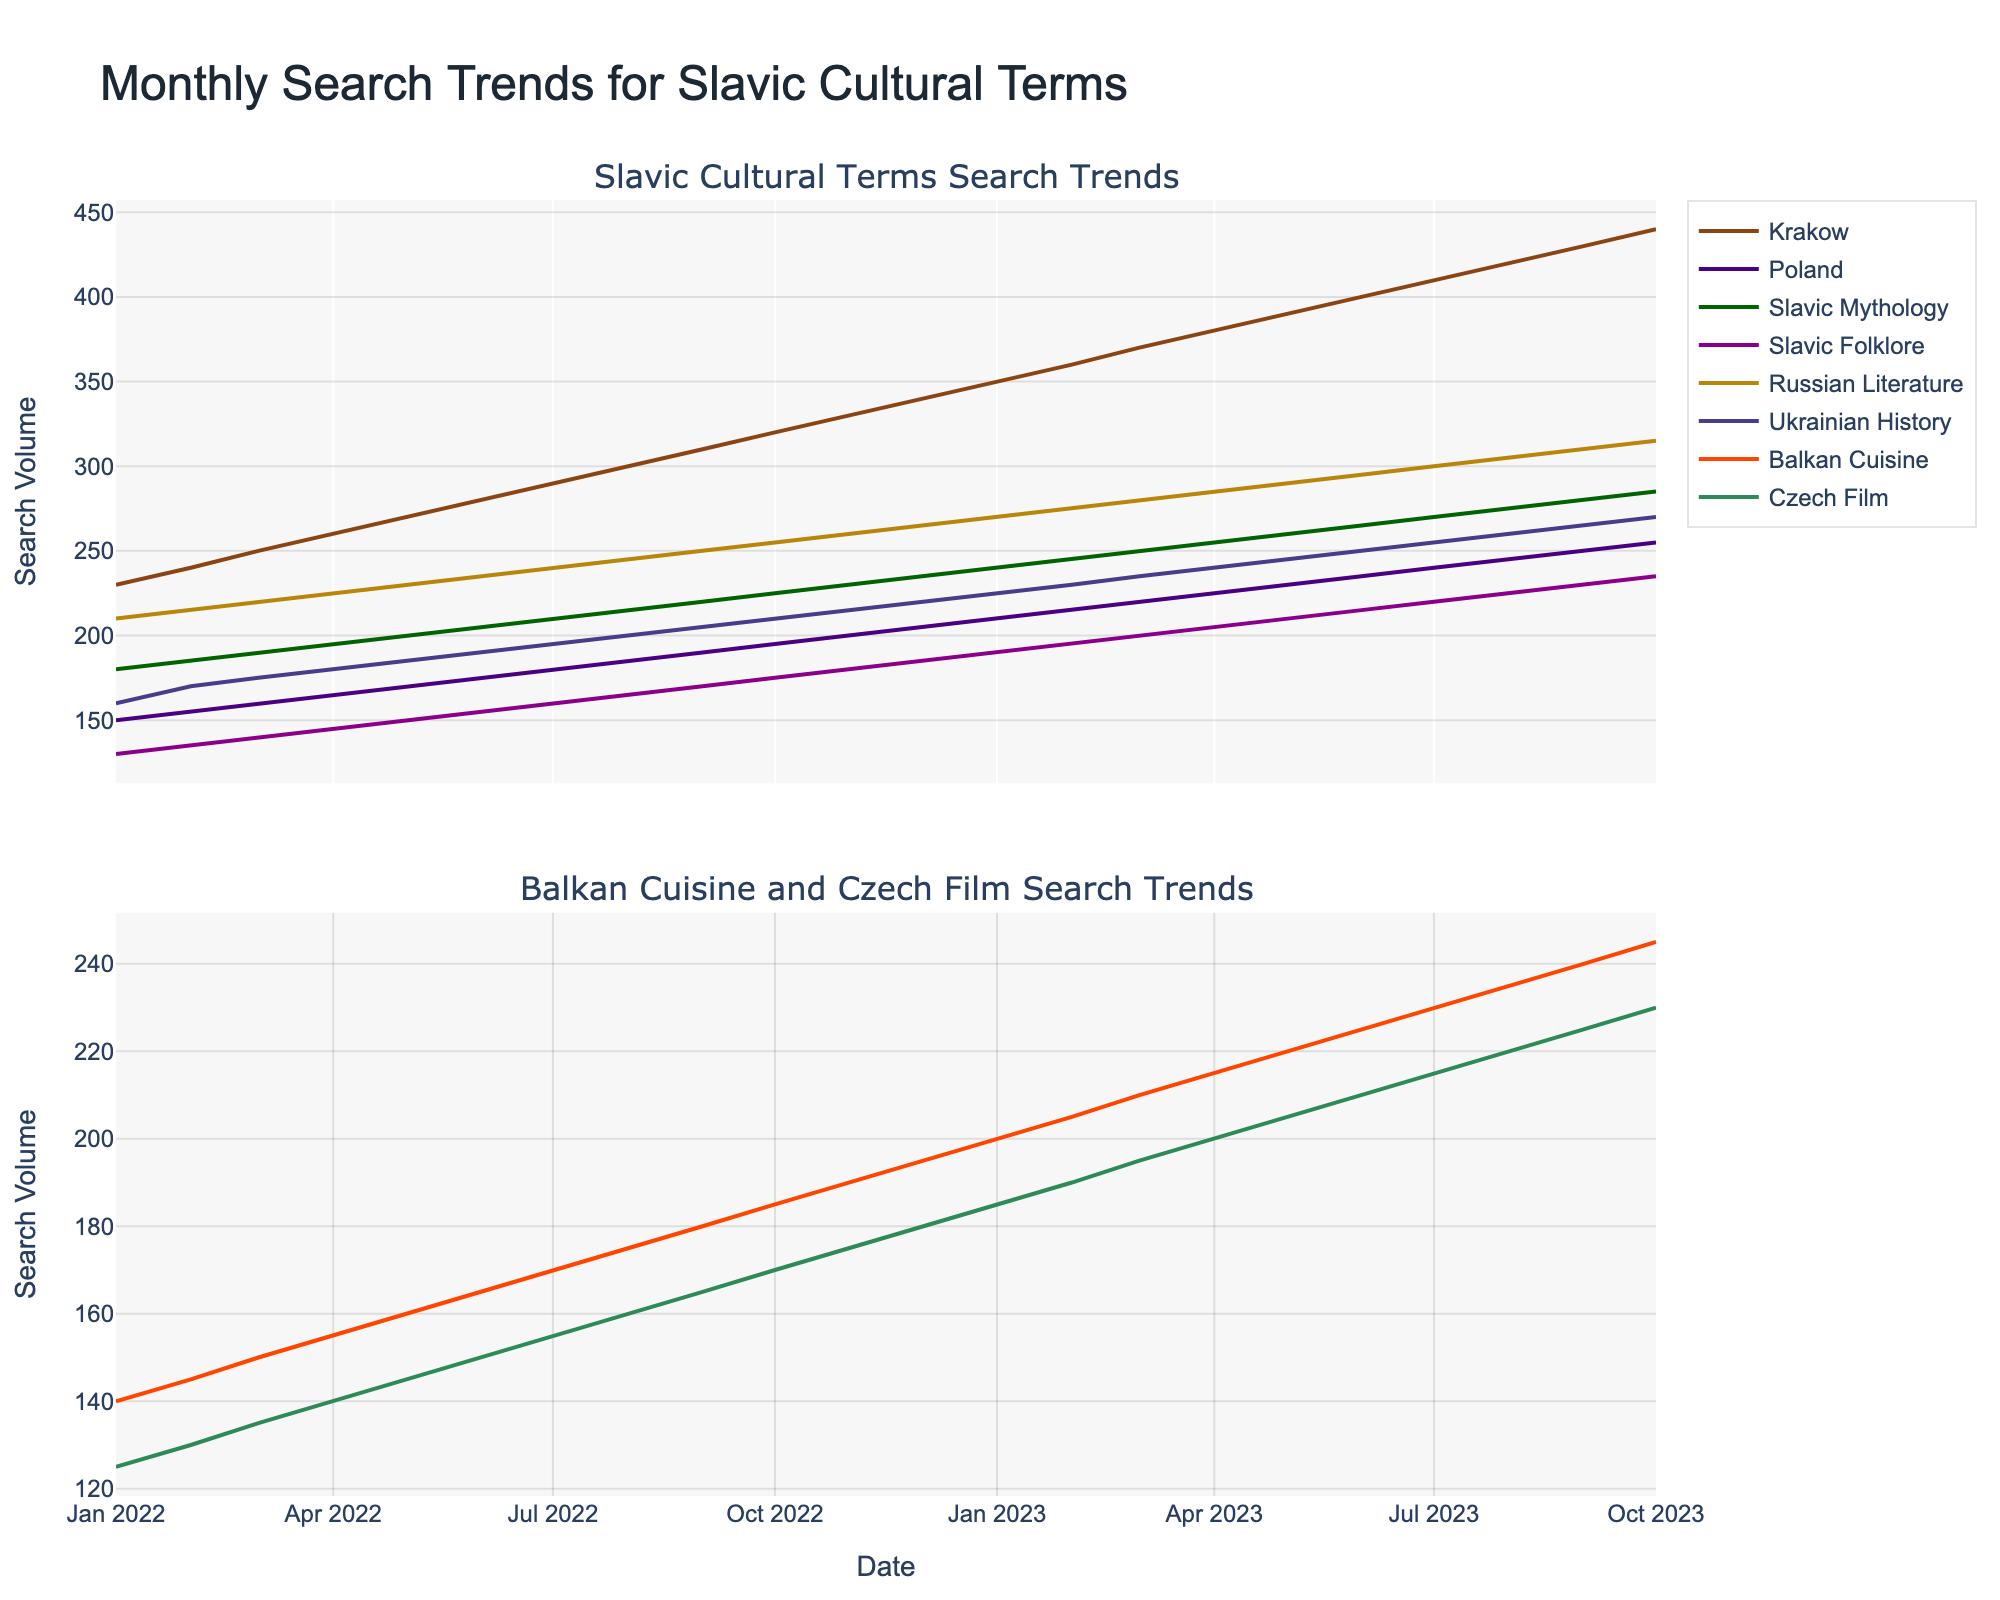What is the title of the plot? The title is prominently displayed at the top of the figure and states the main subject of the plot.
Answer: Monthly Search Trends for Slavic Cultural Terms Which term has the highest search volume in January 2023? Look at the trend lines and identify the point corresponding to January 2023, then check which line is at the highest position on the y-axis.
Answer: Krakow How are the search volumes of 'Balkan Cuisine' and 'Czech Film' in July 2022? Locate the month of July 2022 on the x-axis and trace it upwards to where the lines for 'Balkan Cuisine' and 'Czech Film' intersect. Compare the y-values.
Answer: 170, 155 Did the search volume for 'Russian Literature' ever decrease over the time period shown? Examine the trend line for 'Russian Literature' and check if there is any downward slope or dip within the given time period.
Answer: No Which term showed the greatest increase in search volume from January 2022 to October 2023? Calculate the difference in search volume from January 2022 to October 2023 for each term and compare the differences to find the largest.
Answer: Krakow What is the average search volume for 'Slavic Mythology' across all months? Sum the search volumes for 'Slavic Mythology' across all months and divide by the number of data points (22).
Answer: 232.5 How did the search volume for 'Poland' change from January 2022 to October 2023? Follow the trend line for 'Poland' from January 2022 to October 2023 and describe the progression.
Answer: It increased steadily Which term has the least volatile trend over the period? Compare the smoothness and consistency of the lines for each term, identifying which has the smallest fluctuations.
Answer: Czech Film In which month does 'Ukrainian History' have the same search volume as 'Slavic Folklore'? Look for points where the lines for 'Ukrainian History' and 'Slavic Folklore' intersect on the graph.
Answer: August 2023 How did the search trends for 'Krakow' and 'Balkan Cuisine' compare in February 2023? Identify the search volumes for 'Krakow' and 'Balkan Cuisine' in February 2023, then compare the values.
Answer: Higher for Krakow 